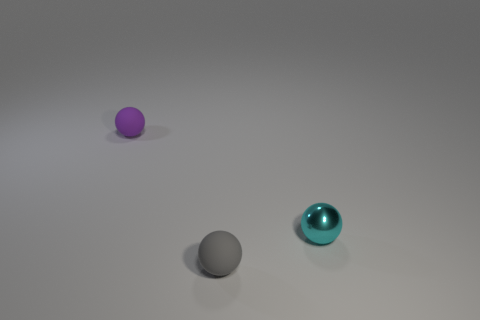What shape is the purple thing that is the same material as the small gray ball?
Make the answer very short. Sphere. Are there any other things that are the same color as the metal sphere?
Keep it short and to the point. No. Is the number of objects that are on the left side of the gray thing greater than the number of small gray rubber balls?
Keep it short and to the point. No. There is a tiny purple thing; is it the same shape as the object on the right side of the small gray matte thing?
Give a very brief answer. Yes. How many other matte things are the same size as the purple object?
Give a very brief answer. 1. What number of purple objects are behind the small cyan sphere that is to the right of the sphere behind the cyan metallic thing?
Offer a very short reply. 1. Is the number of cyan things that are to the right of the small cyan metallic ball the same as the number of tiny purple objects that are in front of the tiny gray matte sphere?
Your answer should be compact. Yes. How many tiny purple objects are the same shape as the tiny cyan object?
Provide a short and direct response. 1. Is there a tiny cylinder that has the same material as the cyan object?
Ensure brevity in your answer.  No. How many cyan metallic balls are there?
Ensure brevity in your answer.  1. 